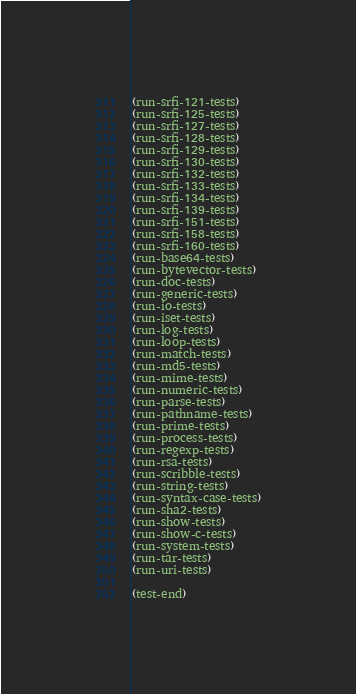<code> <loc_0><loc_0><loc_500><loc_500><_Scheme_>(run-srfi-121-tests)
(run-srfi-125-tests)
(run-srfi-127-tests)
(run-srfi-128-tests)
(run-srfi-129-tests)
(run-srfi-130-tests)
(run-srfi-132-tests)
(run-srfi-133-tests)
(run-srfi-134-tests)
(run-srfi-139-tests)
(run-srfi-151-tests)
(run-srfi-158-tests)
(run-srfi-160-tests)
(run-base64-tests)
(run-bytevector-tests)
(run-doc-tests)
(run-generic-tests)
(run-io-tests)
(run-iset-tests)
(run-log-tests)
(run-loop-tests)
(run-match-tests)
(run-md5-tests)
(run-mime-tests)
(run-numeric-tests)
(run-parse-tests)
(run-pathname-tests)
(run-prime-tests)
(run-process-tests)
(run-regexp-tests)
(run-rsa-tests)
(run-scribble-tests)
(run-string-tests)
(run-syntax-case-tests)
(run-sha2-tests)
(run-show-tests)
(run-show-c-tests)
(run-system-tests)
(run-tar-tests)
(run-uri-tests)

(test-end)
</code> 